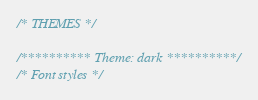<code> <loc_0><loc_0><loc_500><loc_500><_CSS_>/* THEMES */

/********** Theme: dark **********/
/* Font styles */</code> 